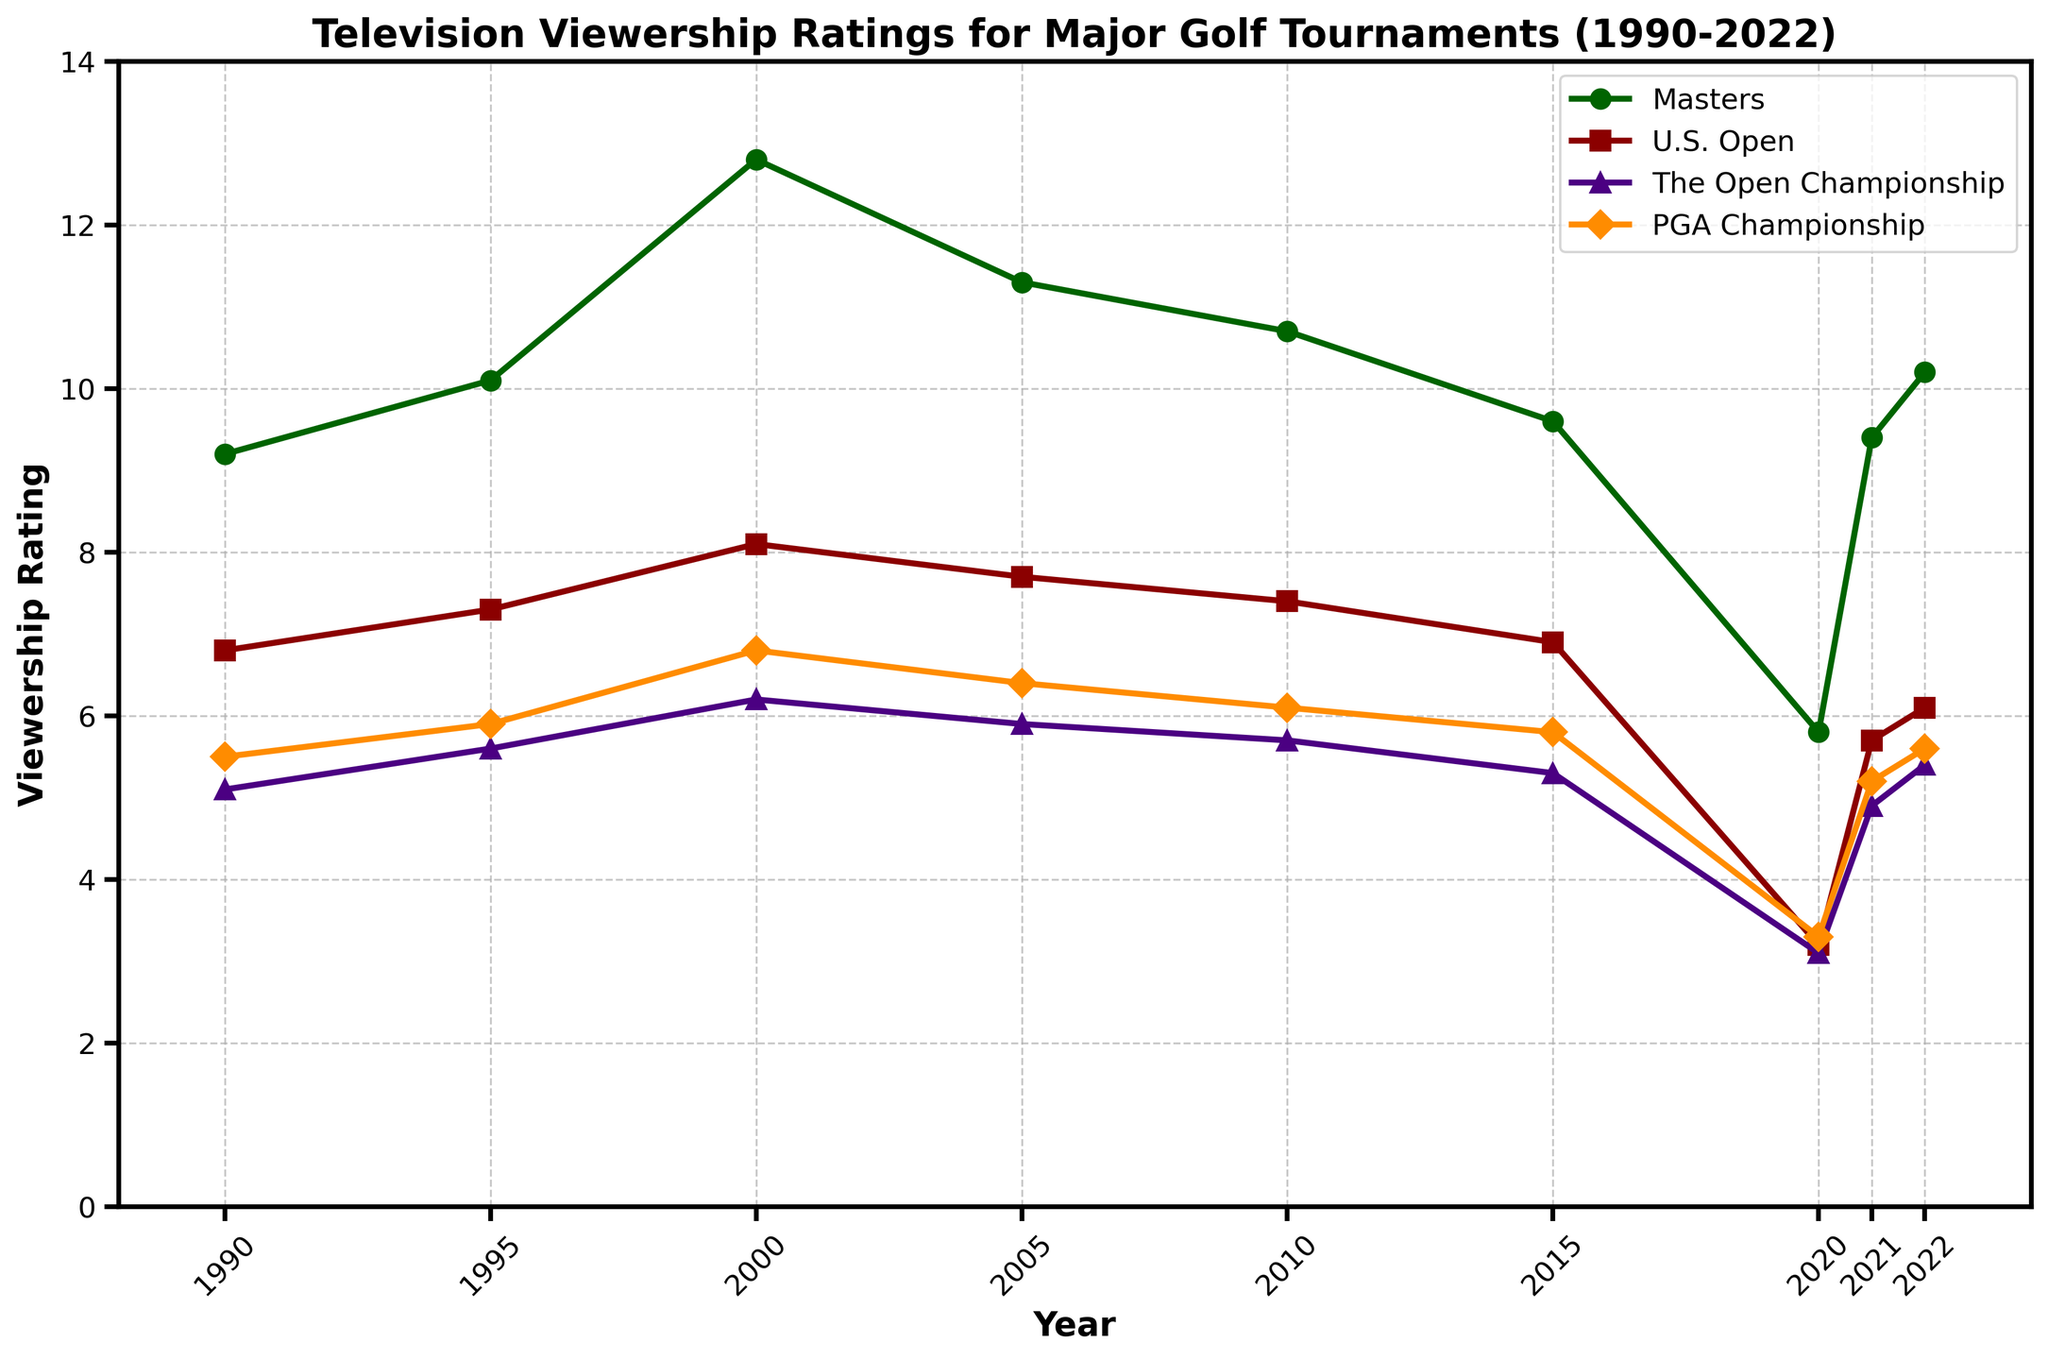How do the viewership ratings of the Masters in 2000 compare to those in 2020? To determine this, we need to look at the ratings for the Masters in both 2000 and 2020. In 2000, the rating for the Masters was 12.8. In 2020, it was 5.8. Comparing these values, we see a decrease.
Answer: The rating in 2020 (5.8) is significantly lower than in 2000 (12.8) In which year did the U.S. Open have its lowest viewership rating according to the figure? We need to look at the ratings for the U.S. Open across all years and identify the lowest value. The lowest rating is in 2020 with a rating of 3.2.
Answer: 2020 Calculate the average viewership rating of the PGA Championship from 1995 to 2005. Sum the ratings for the specified years and divide by the number of years. Ratings are 5.9 (1995), 6.8 (2000), 6.4 (2005). Average = (5.9 + 6.8 + 6.4) / 3 = 6.37
Answer: 6.37 Which tournament showed the highest increase in viewership rating from 2020 to 2022? Calculate the difference in ratings from 2020 to 2022 for each tournament: Masters (10.2-5.8)=4.4, U.S. Open (6.1-3.2)=2.9, The Open Championship (5.4-3.1)=2.3, PGA Championship (5.6-3.3)=2.3. The highest increase is for the Masters.
Answer: The Masters Compare the viewership ratings between the Masters and The Open Championship in 2010. Which had higher ratings and by how much? Look at the ratings for both tournaments in 2010. The Masters had a rating of 10.7, while The Open Championship had 5.7. The difference is 10.7 - 5.7 = 5.0.
Answer: The Masters by 5.0 Identify a year where the viewership rating for U.S. Open and PGA Championship were closest. Mention the year and the ratings. Compare the differences in ratings for all years. The closest gap is in 2021 with the U.S. Open (5.7) and PGA Championship (5.2), with a difference of 0.5.
Answer: 2021, U.S. Open: 5.7, PGA Championship: 5.2 What are the general trends in viewership ratings for the Masters and U.S. Open from 1990 to 2022? Look at the plotted lines for the Masters and U.S. Open. The Masters shows a general decline after a peak around 2000, while the U.S. Open has a more consistent downward trend throughout the years, with a slight increase in recent years.
Answer: Masters: peaked around 2000, then decline. U.S. Open: consistent decline with recent slight increase 